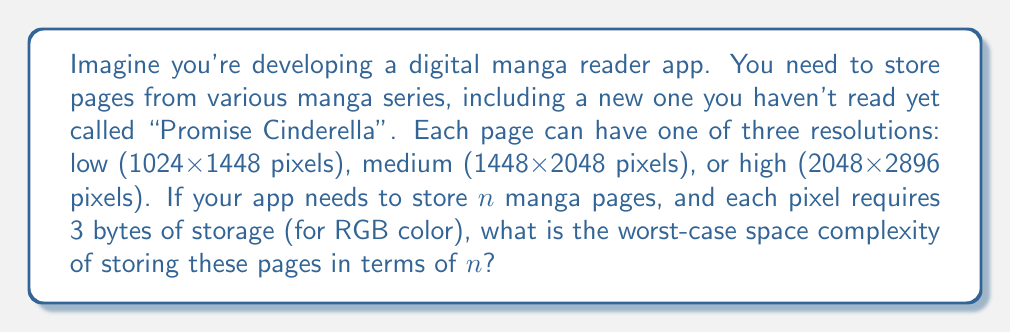Show me your answer to this math problem. Let's approach this step-by-step:

1) First, we need to calculate the storage required for each resolution:

   Low: $1024 \times 1448 \times 3 = 4,448,256$ bytes
   Medium: $1448 \times 2048 \times 3 = 8,912,896$ bytes
   High: $2048 \times 2896 \times 3 = 17,825,792$ bytes

2) The worst-case scenario would be if all $n$ pages were at the highest resolution.

3) In this case, the total storage would be:

   $n \times 17,825,792$ bytes

4) In Big O notation, we're interested in the growth rate with respect to $n$, not the constant factors. So we can simplify this to:

   $O(n)$

5) The space complexity is linear with respect to the number of pages $n$.

6) It's worth noting that while the constant factor (17,825,792 in this case) is quite large, it doesn't affect the Big O notation. However, in practical applications, this constant factor would be significant for performance and storage considerations.
Answer: The worst-case space complexity is $O(n)$, where $n$ is the number of manga pages. 